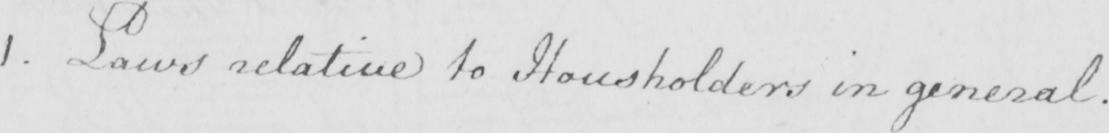What text is written in this handwritten line? 1. Laws relative to Householders in general. 